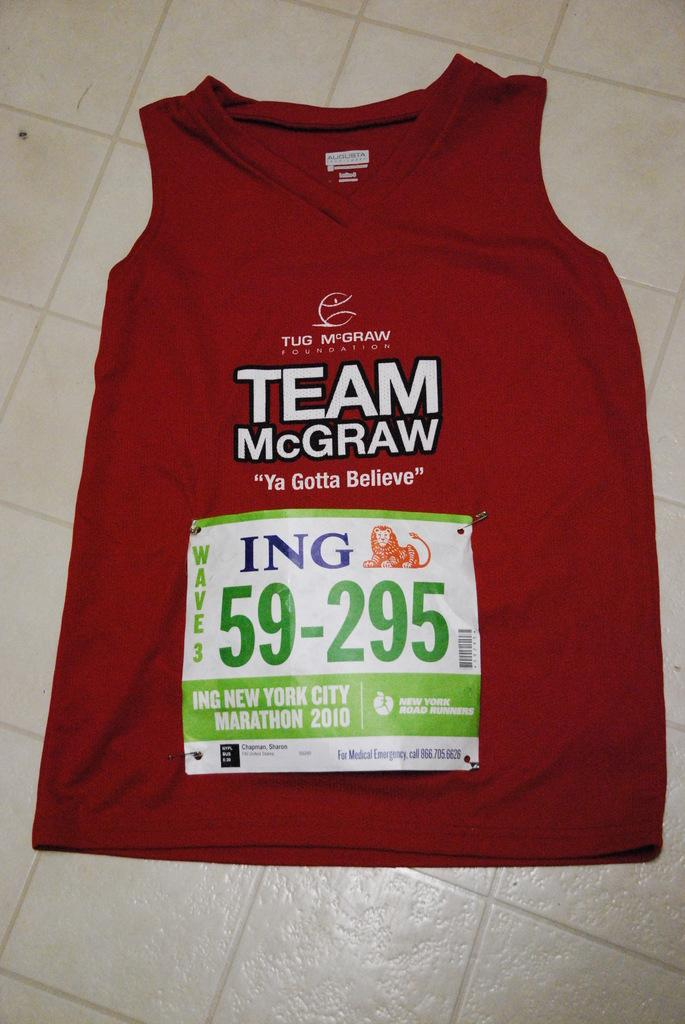<image>
Provide a brief description of the given image. a shirt that has the words Team McGraw on it 